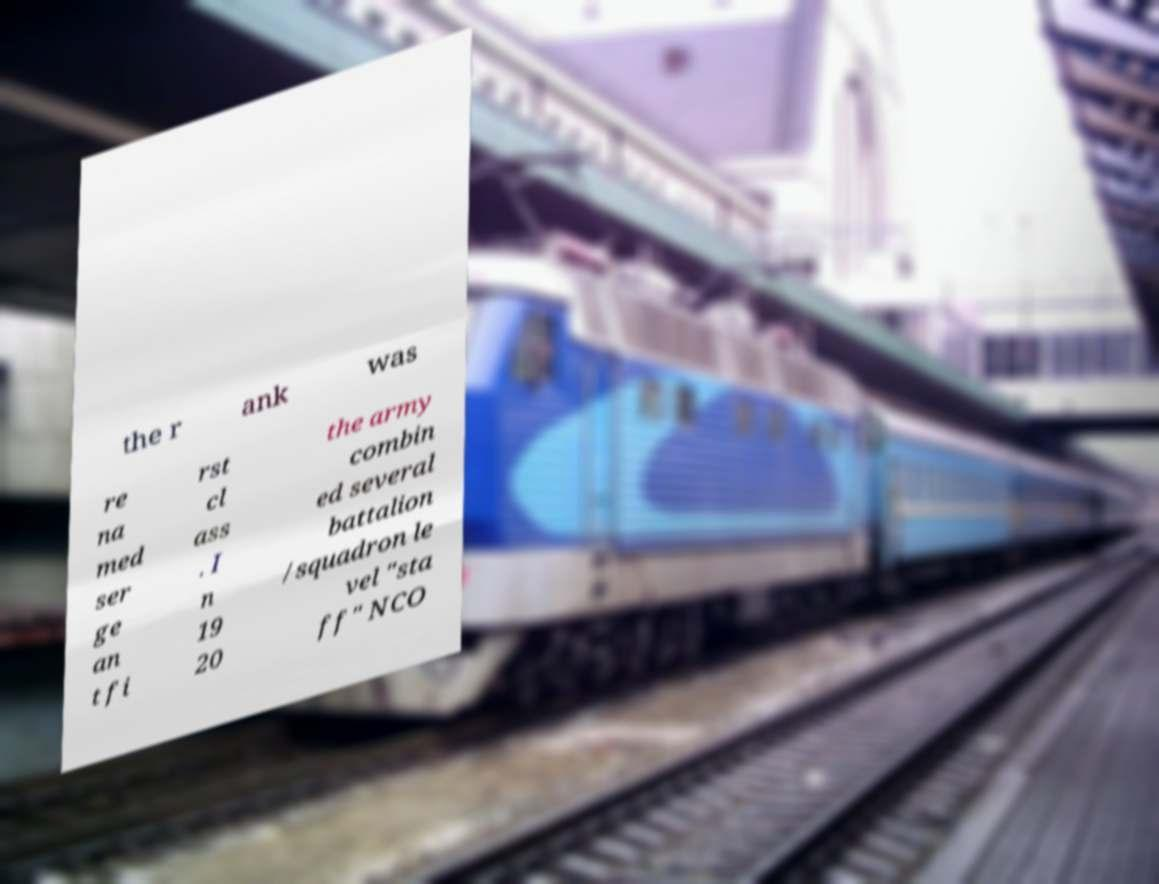Can you read and provide the text displayed in the image?This photo seems to have some interesting text. Can you extract and type it out for me? the r ank was re na med ser ge an t fi rst cl ass . I n 19 20 the army combin ed several battalion /squadron le vel "sta ff" NCO 